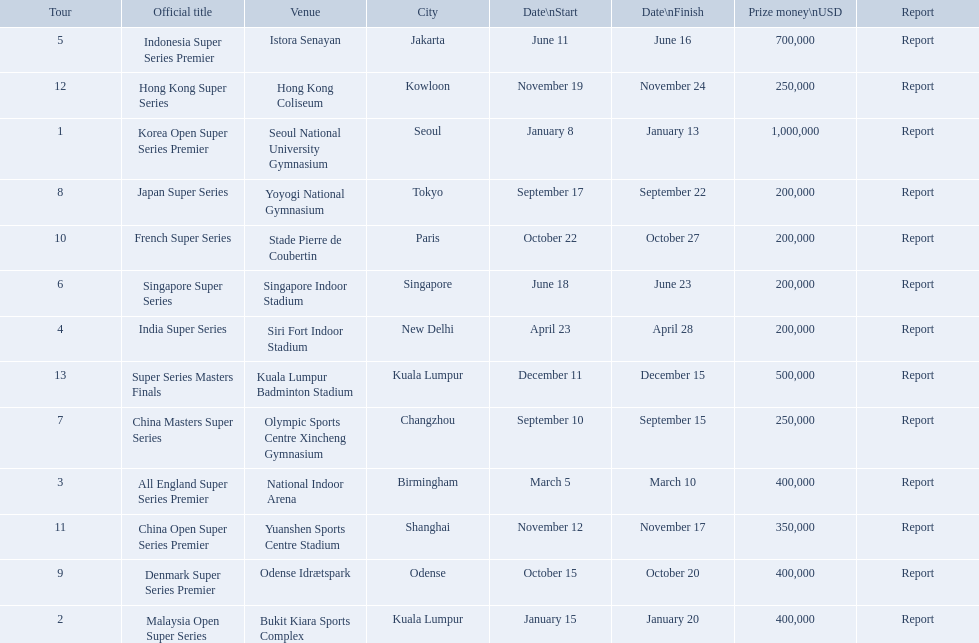What are all the tours? Korea Open Super Series Premier, Malaysia Open Super Series, All England Super Series Premier, India Super Series, Indonesia Super Series Premier, Singapore Super Series, China Masters Super Series, Japan Super Series, Denmark Super Series Premier, French Super Series, China Open Super Series Premier, Hong Kong Super Series, Super Series Masters Finals. What were the start dates of these tours? January 8, January 15, March 5, April 23, June 11, June 18, September 10, September 17, October 15, October 22, November 12, November 19, December 11. Of these, which is in december? December 11. Which tour started on this date? Super Series Masters Finals. 